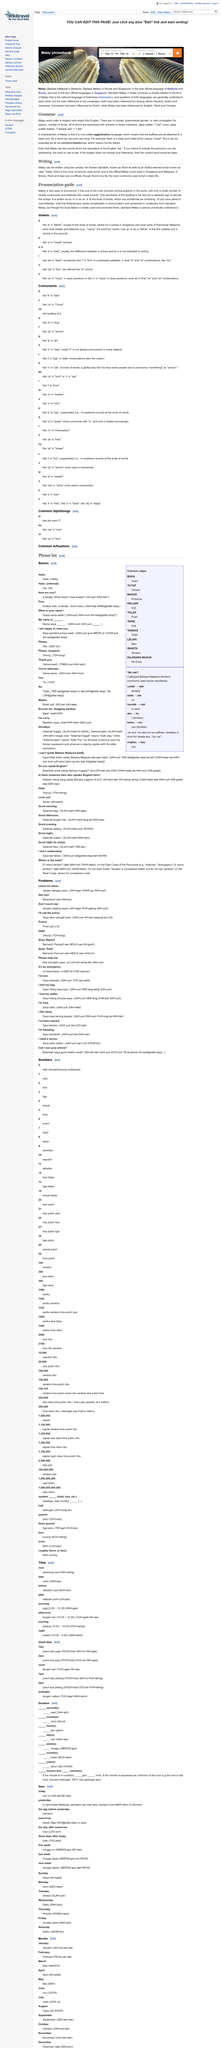List a handful of essential elements in this visual. In linguistics, the term "agglutinative" refers to a type of grammatical structure in which suffixes are attached to a base root to form a word, rather than the word being formed by the combination of a root and a prefix or a suffix. Malay in Kelantan varies greatly in pronunciation and somewhat in vocabulary. When writing in Malay, two scripts, Rumi and Jawi, can be utilized. The official Malay script used in Singapore and Malaysia is Rumi. Malay is an agglutinative language, which is a characteristic of the language. 